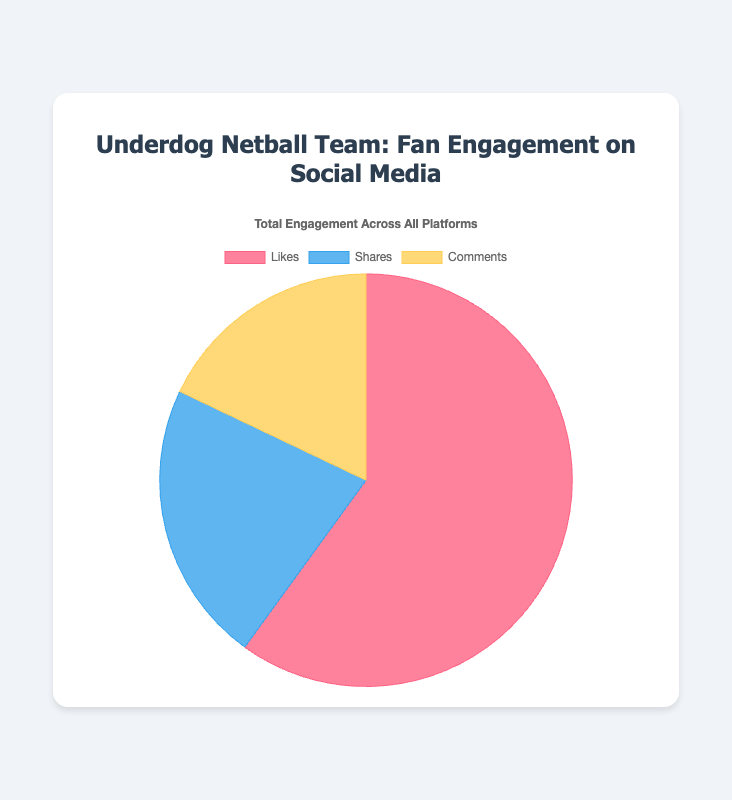Which type of fan engagement has the highest value across all platforms? To determine which type of engagement has the highest value, we compare Likes, Shares, and Comments. The values are 7500 for Likes, 2760 for Shares, and 2240 for Comments. Therefore, Likes have the highest value.
Answer: Likes Which type of fan engagement has the lowest value across all platforms? We compare the values for each engagement type: Likes (7500), Shares (2760), and Comments (2240). The lowest value among these is for Comments.
Answer: Comments What is the total number of Shares across all social media platforms? The values for Shares are given as 1100 (Facebook), 900 (Twitter), and 760 (Instagram). Summing these values, 1100 + 900 + 760 = 2760.
Answer: 2760 How much higher is the total number of Likes compared to Comments? Likes are 7500 and Comments are 2240. The difference is 7500 - 2240.
Answer: 5260 What percentage of the total engagement is represented by Shares? Total engagement = Likes + Shares + Comments = 7500 + 2760 + 2240 = 12500. The percentage for Shares is (2760 / 12500) * 100.
Answer: 22.08% Are Shares more than Comments across all platforms combined? Shares total 2760 and Comments total 2240. Since 2760 is greater than 2240, Shares are more than Comments.
Answer: Yes What is the average number of Likes per platform? Total Likes = 7500. Number of platforms = 3. Average Likes = 7500 / 3.
Answer: 2500 Which engagement type has the closest value to 3000? The values are Likes (7500), Shares (2760), and Comments (2240). Shares (2760) is the closest to 3000.
Answer: Shares What is the combined total of Likes and Comments? Likes = 7500, Comments = 2240. The sum is 7500 + 2240.
Answer: 9740 